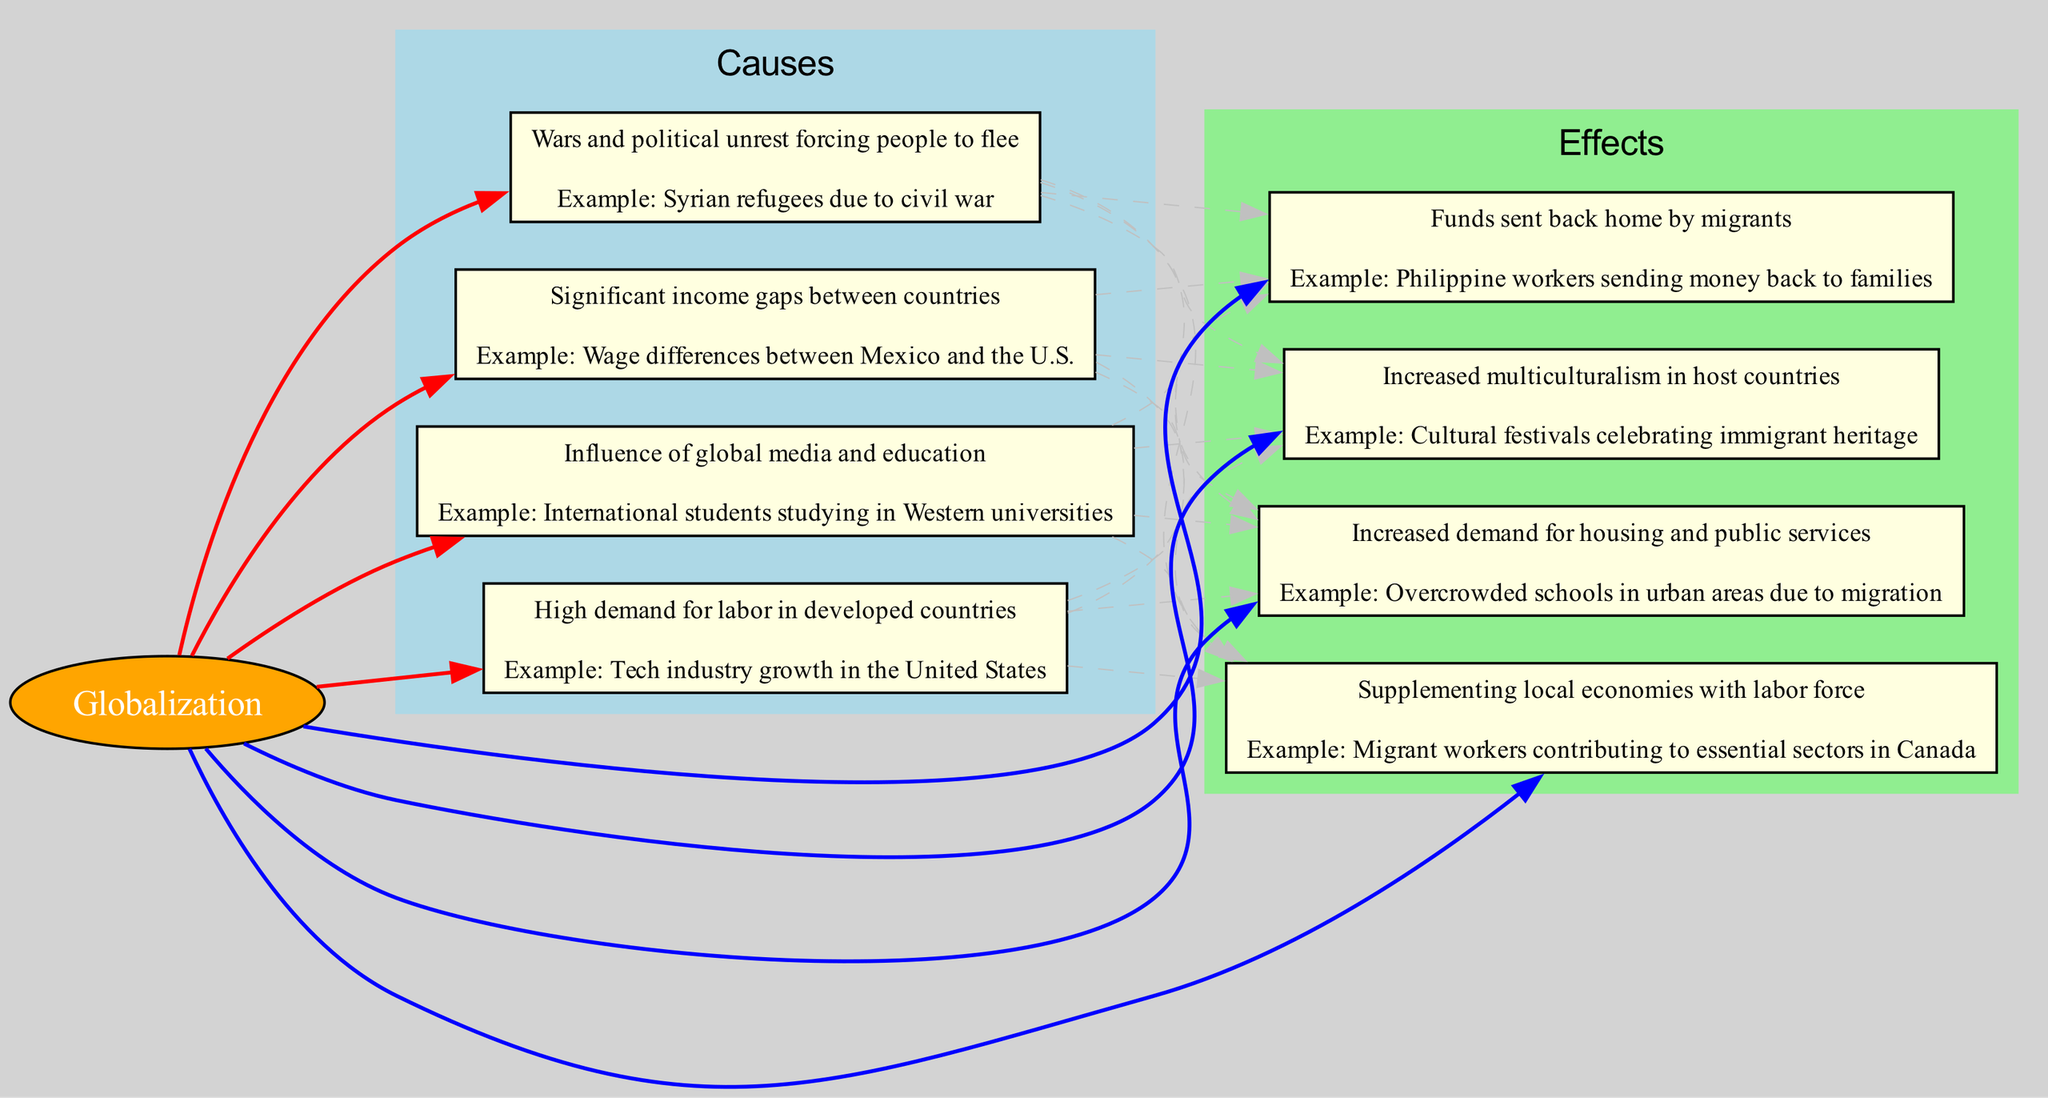What are the four main causes of migration in this chart? The chart lists four causes of migration: job availability, cultural exchange, economic disparities, and conflict and instability. This can be determined by looking at the 'Causes' section of the diagram where these factors are clearly denoted.
Answer: job availability, cultural exchange, economic disparities, conflict and instability How many effects of migration are indicated in the chart? The diagram illustrates four effects of migration: remittance flows, cultural diversity, strain on resources, and economic growth, which are categorized under the 'Effects' section. Counting these nodes gives the total.
Answer: four Which cause is linked to the effect of 'remittance flows'? The cause linked to 'remittance flows' is economic disparities. The diagram indicates connections (edges) between the causes and effects, and analyzing the edge from the cause economic disparities to the effect remittance flows confirms this relationship.
Answer: economic disparities What type of edge connects the causes to effects in this diagram? The edges that connect the causes to the effects are styled as dashed, which is a specific characteristic of the connections made in this flow chart. The edge style is indicated visually next to the connections in the diagram.
Answer: dashed How do cultural exchange and conflict and instability relate to migration? Both cultural exchange and conflict and instability are listed as causes of migration. The diagram shows these causes feeding into the central concept of globalization, illustrating how they drive people to migrate.
Answer: causes of migration What effect is associated with increased demand for housing and public services? The effect associated with increased demand for housing and public services is strain on resources. This is indicated in the 'Effects' section of the chart, where it is explicitly described.
Answer: strain on resources Which country is used as an example for economic disparities in the causes section? The example used for economic disparities in the chart is the wage differences between Mexico and the U.S. This can be verified by checking the description within the economic disparities node in the diagram.
Answer: Mexico and the U.S What graphical feature distinguishes the central node of the diagram? The central node of the diagram, labeled as globalization, is distinguished by being an ellipse shape and filled with orange color. These graphical features set it apart from the rectangular shaped nodes for causes and effects.
Answer: ellipse and orange color How does the diagram illustrate the relationship between globalization and migration? The diagram illustrates the relationship by connecting the central node labeled globalization to all the cause nodes with bold red edges and to the effect nodes with bold blue edges. This visually indicates that globalization influences both causes and effects of migration.
Answer: with bold edges 